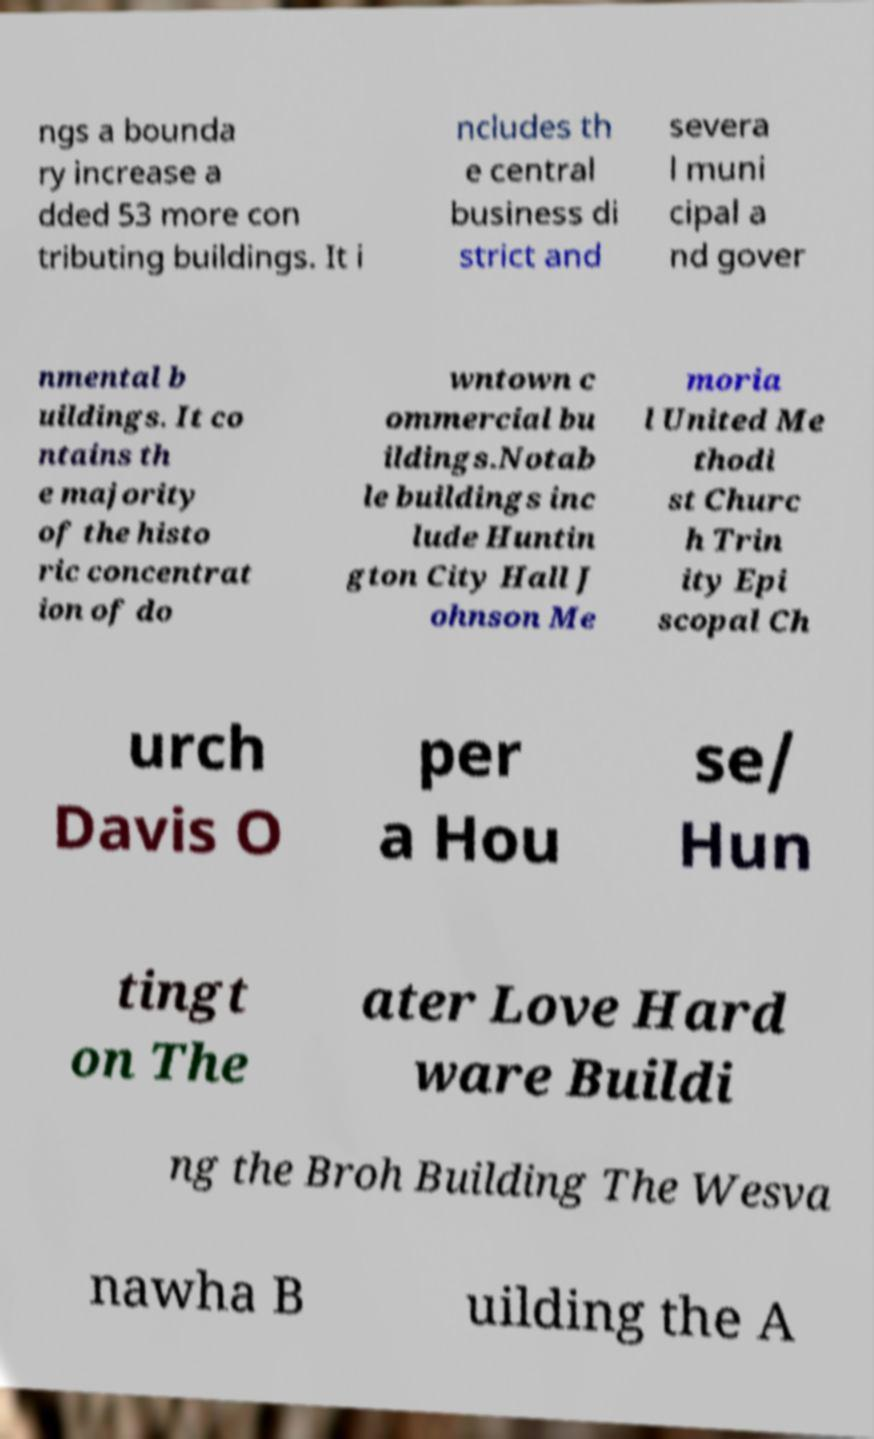Can you accurately transcribe the text from the provided image for me? ngs a bounda ry increase a dded 53 more con tributing buildings. It i ncludes th e central business di strict and severa l muni cipal a nd gover nmental b uildings. It co ntains th e majority of the histo ric concentrat ion of do wntown c ommercial bu ildings.Notab le buildings inc lude Huntin gton City Hall J ohnson Me moria l United Me thodi st Churc h Trin ity Epi scopal Ch urch Davis O per a Hou se/ Hun tingt on The ater Love Hard ware Buildi ng the Broh Building The Wesva nawha B uilding the A 